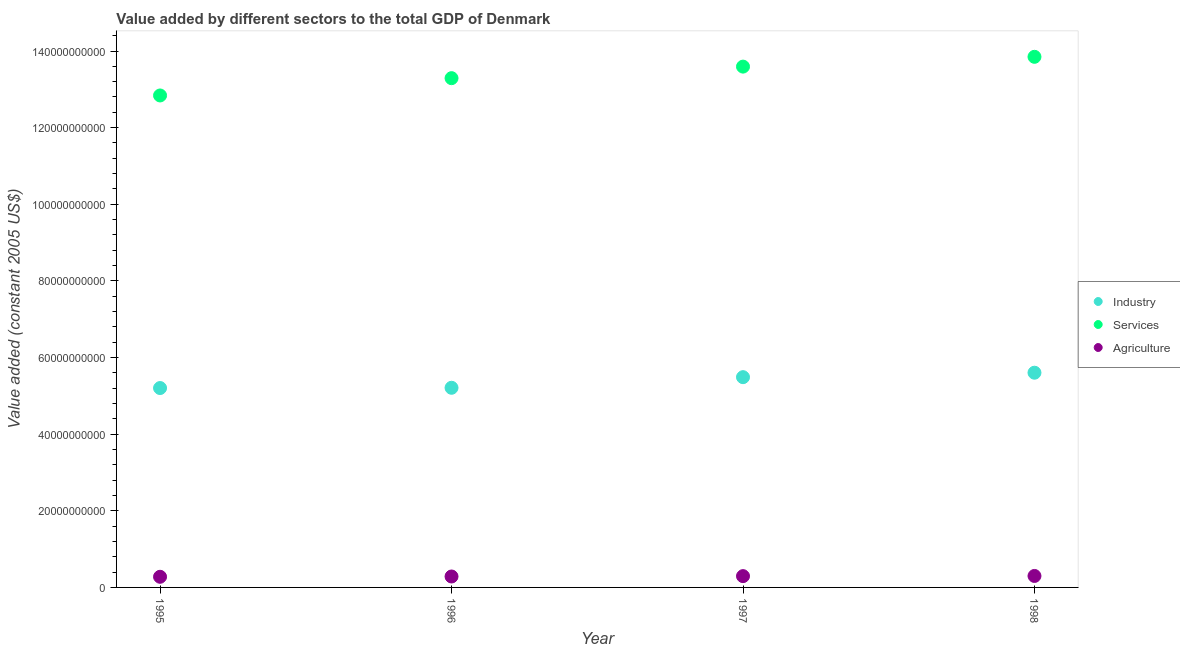What is the value added by services in 1997?
Offer a terse response. 1.36e+11. Across all years, what is the maximum value added by services?
Provide a succinct answer. 1.38e+11. Across all years, what is the minimum value added by industrial sector?
Make the answer very short. 5.20e+1. In which year was the value added by agricultural sector minimum?
Make the answer very short. 1995. What is the total value added by industrial sector in the graph?
Offer a terse response. 2.15e+11. What is the difference between the value added by industrial sector in 1995 and that in 1997?
Make the answer very short. -2.84e+09. What is the difference between the value added by industrial sector in 1997 and the value added by agricultural sector in 1998?
Your response must be concise. 5.19e+1. What is the average value added by services per year?
Offer a very short reply. 1.34e+11. In the year 1996, what is the difference between the value added by agricultural sector and value added by industrial sector?
Your answer should be compact. -4.93e+1. What is the ratio of the value added by services in 1995 to that in 1996?
Keep it short and to the point. 0.97. Is the value added by industrial sector in 1996 less than that in 1997?
Offer a terse response. Yes. What is the difference between the highest and the second highest value added by services?
Provide a short and direct response. 2.56e+09. What is the difference between the highest and the lowest value added by agricultural sector?
Your response must be concise. 2.16e+08. In how many years, is the value added by industrial sector greater than the average value added by industrial sector taken over all years?
Make the answer very short. 2. Does the value added by services monotonically increase over the years?
Make the answer very short. Yes. How many dotlines are there?
Your answer should be very brief. 3. How many years are there in the graph?
Ensure brevity in your answer.  4. What is the difference between two consecutive major ticks on the Y-axis?
Ensure brevity in your answer.  2.00e+1. Does the graph contain any zero values?
Offer a terse response. No. Does the graph contain grids?
Keep it short and to the point. No. How are the legend labels stacked?
Give a very brief answer. Vertical. What is the title of the graph?
Your answer should be compact. Value added by different sectors to the total GDP of Denmark. What is the label or title of the X-axis?
Make the answer very short. Year. What is the label or title of the Y-axis?
Your answer should be very brief. Value added (constant 2005 US$). What is the Value added (constant 2005 US$) of Industry in 1995?
Ensure brevity in your answer.  5.20e+1. What is the Value added (constant 2005 US$) in Services in 1995?
Offer a terse response. 1.28e+11. What is the Value added (constant 2005 US$) of Agriculture in 1995?
Ensure brevity in your answer.  2.78e+09. What is the Value added (constant 2005 US$) in Industry in 1996?
Give a very brief answer. 5.21e+1. What is the Value added (constant 2005 US$) in Services in 1996?
Give a very brief answer. 1.33e+11. What is the Value added (constant 2005 US$) of Agriculture in 1996?
Keep it short and to the point. 2.85e+09. What is the Value added (constant 2005 US$) of Industry in 1997?
Provide a succinct answer. 5.49e+1. What is the Value added (constant 2005 US$) of Services in 1997?
Provide a short and direct response. 1.36e+11. What is the Value added (constant 2005 US$) in Agriculture in 1997?
Your answer should be very brief. 2.95e+09. What is the Value added (constant 2005 US$) in Industry in 1998?
Give a very brief answer. 5.60e+1. What is the Value added (constant 2005 US$) in Services in 1998?
Keep it short and to the point. 1.38e+11. What is the Value added (constant 2005 US$) of Agriculture in 1998?
Ensure brevity in your answer.  2.99e+09. Across all years, what is the maximum Value added (constant 2005 US$) in Industry?
Your response must be concise. 5.60e+1. Across all years, what is the maximum Value added (constant 2005 US$) of Services?
Your response must be concise. 1.38e+11. Across all years, what is the maximum Value added (constant 2005 US$) of Agriculture?
Your response must be concise. 2.99e+09. Across all years, what is the minimum Value added (constant 2005 US$) of Industry?
Make the answer very short. 5.20e+1. Across all years, what is the minimum Value added (constant 2005 US$) in Services?
Provide a succinct answer. 1.28e+11. Across all years, what is the minimum Value added (constant 2005 US$) in Agriculture?
Provide a succinct answer. 2.78e+09. What is the total Value added (constant 2005 US$) in Industry in the graph?
Offer a very short reply. 2.15e+11. What is the total Value added (constant 2005 US$) in Services in the graph?
Provide a short and direct response. 5.36e+11. What is the total Value added (constant 2005 US$) in Agriculture in the graph?
Provide a short and direct response. 1.16e+1. What is the difference between the Value added (constant 2005 US$) in Industry in 1995 and that in 1996?
Your answer should be very brief. -6.66e+07. What is the difference between the Value added (constant 2005 US$) in Services in 1995 and that in 1996?
Provide a short and direct response. -4.52e+09. What is the difference between the Value added (constant 2005 US$) of Agriculture in 1995 and that in 1996?
Keep it short and to the point. -7.56e+07. What is the difference between the Value added (constant 2005 US$) in Industry in 1995 and that in 1997?
Provide a succinct answer. -2.84e+09. What is the difference between the Value added (constant 2005 US$) in Services in 1995 and that in 1997?
Your answer should be compact. -7.53e+09. What is the difference between the Value added (constant 2005 US$) of Agriculture in 1995 and that in 1997?
Your response must be concise. -1.71e+08. What is the difference between the Value added (constant 2005 US$) in Industry in 1995 and that in 1998?
Offer a very short reply. -4.00e+09. What is the difference between the Value added (constant 2005 US$) in Services in 1995 and that in 1998?
Offer a very short reply. -1.01e+1. What is the difference between the Value added (constant 2005 US$) of Agriculture in 1995 and that in 1998?
Provide a succinct answer. -2.16e+08. What is the difference between the Value added (constant 2005 US$) of Industry in 1996 and that in 1997?
Provide a short and direct response. -2.77e+09. What is the difference between the Value added (constant 2005 US$) of Services in 1996 and that in 1997?
Make the answer very short. -3.01e+09. What is the difference between the Value added (constant 2005 US$) in Agriculture in 1996 and that in 1997?
Your response must be concise. -9.59e+07. What is the difference between the Value added (constant 2005 US$) in Industry in 1996 and that in 1998?
Offer a terse response. -3.93e+09. What is the difference between the Value added (constant 2005 US$) in Services in 1996 and that in 1998?
Your response must be concise. -5.57e+09. What is the difference between the Value added (constant 2005 US$) of Agriculture in 1996 and that in 1998?
Offer a terse response. -1.40e+08. What is the difference between the Value added (constant 2005 US$) of Industry in 1997 and that in 1998?
Your answer should be very brief. -1.16e+09. What is the difference between the Value added (constant 2005 US$) in Services in 1997 and that in 1998?
Your answer should be compact. -2.56e+09. What is the difference between the Value added (constant 2005 US$) in Agriculture in 1997 and that in 1998?
Ensure brevity in your answer.  -4.46e+07. What is the difference between the Value added (constant 2005 US$) in Industry in 1995 and the Value added (constant 2005 US$) in Services in 1996?
Give a very brief answer. -8.09e+1. What is the difference between the Value added (constant 2005 US$) in Industry in 1995 and the Value added (constant 2005 US$) in Agriculture in 1996?
Ensure brevity in your answer.  4.92e+1. What is the difference between the Value added (constant 2005 US$) in Services in 1995 and the Value added (constant 2005 US$) in Agriculture in 1996?
Your answer should be very brief. 1.26e+11. What is the difference between the Value added (constant 2005 US$) in Industry in 1995 and the Value added (constant 2005 US$) in Services in 1997?
Your response must be concise. -8.39e+1. What is the difference between the Value added (constant 2005 US$) of Industry in 1995 and the Value added (constant 2005 US$) of Agriculture in 1997?
Offer a very short reply. 4.91e+1. What is the difference between the Value added (constant 2005 US$) of Services in 1995 and the Value added (constant 2005 US$) of Agriculture in 1997?
Offer a very short reply. 1.25e+11. What is the difference between the Value added (constant 2005 US$) in Industry in 1995 and the Value added (constant 2005 US$) in Services in 1998?
Your response must be concise. -8.64e+1. What is the difference between the Value added (constant 2005 US$) in Industry in 1995 and the Value added (constant 2005 US$) in Agriculture in 1998?
Provide a succinct answer. 4.90e+1. What is the difference between the Value added (constant 2005 US$) of Services in 1995 and the Value added (constant 2005 US$) of Agriculture in 1998?
Give a very brief answer. 1.25e+11. What is the difference between the Value added (constant 2005 US$) in Industry in 1996 and the Value added (constant 2005 US$) in Services in 1997?
Make the answer very short. -8.38e+1. What is the difference between the Value added (constant 2005 US$) of Industry in 1996 and the Value added (constant 2005 US$) of Agriculture in 1997?
Your response must be concise. 4.92e+1. What is the difference between the Value added (constant 2005 US$) in Services in 1996 and the Value added (constant 2005 US$) in Agriculture in 1997?
Provide a succinct answer. 1.30e+11. What is the difference between the Value added (constant 2005 US$) of Industry in 1996 and the Value added (constant 2005 US$) of Services in 1998?
Offer a very short reply. -8.64e+1. What is the difference between the Value added (constant 2005 US$) of Industry in 1996 and the Value added (constant 2005 US$) of Agriculture in 1998?
Offer a very short reply. 4.91e+1. What is the difference between the Value added (constant 2005 US$) of Services in 1996 and the Value added (constant 2005 US$) of Agriculture in 1998?
Your answer should be very brief. 1.30e+11. What is the difference between the Value added (constant 2005 US$) in Industry in 1997 and the Value added (constant 2005 US$) in Services in 1998?
Your answer should be very brief. -8.36e+1. What is the difference between the Value added (constant 2005 US$) in Industry in 1997 and the Value added (constant 2005 US$) in Agriculture in 1998?
Offer a terse response. 5.19e+1. What is the difference between the Value added (constant 2005 US$) of Services in 1997 and the Value added (constant 2005 US$) of Agriculture in 1998?
Ensure brevity in your answer.  1.33e+11. What is the average Value added (constant 2005 US$) in Industry per year?
Provide a succinct answer. 5.38e+1. What is the average Value added (constant 2005 US$) in Services per year?
Offer a very short reply. 1.34e+11. What is the average Value added (constant 2005 US$) of Agriculture per year?
Your response must be concise. 2.89e+09. In the year 1995, what is the difference between the Value added (constant 2005 US$) in Industry and Value added (constant 2005 US$) in Services?
Your answer should be compact. -7.64e+1. In the year 1995, what is the difference between the Value added (constant 2005 US$) in Industry and Value added (constant 2005 US$) in Agriculture?
Provide a succinct answer. 4.93e+1. In the year 1995, what is the difference between the Value added (constant 2005 US$) of Services and Value added (constant 2005 US$) of Agriculture?
Offer a terse response. 1.26e+11. In the year 1996, what is the difference between the Value added (constant 2005 US$) in Industry and Value added (constant 2005 US$) in Services?
Offer a terse response. -8.08e+1. In the year 1996, what is the difference between the Value added (constant 2005 US$) of Industry and Value added (constant 2005 US$) of Agriculture?
Offer a terse response. 4.93e+1. In the year 1996, what is the difference between the Value added (constant 2005 US$) of Services and Value added (constant 2005 US$) of Agriculture?
Your response must be concise. 1.30e+11. In the year 1997, what is the difference between the Value added (constant 2005 US$) in Industry and Value added (constant 2005 US$) in Services?
Provide a succinct answer. -8.10e+1. In the year 1997, what is the difference between the Value added (constant 2005 US$) of Industry and Value added (constant 2005 US$) of Agriculture?
Your response must be concise. 5.19e+1. In the year 1997, what is the difference between the Value added (constant 2005 US$) in Services and Value added (constant 2005 US$) in Agriculture?
Provide a succinct answer. 1.33e+11. In the year 1998, what is the difference between the Value added (constant 2005 US$) in Industry and Value added (constant 2005 US$) in Services?
Ensure brevity in your answer.  -8.24e+1. In the year 1998, what is the difference between the Value added (constant 2005 US$) of Industry and Value added (constant 2005 US$) of Agriculture?
Give a very brief answer. 5.30e+1. In the year 1998, what is the difference between the Value added (constant 2005 US$) in Services and Value added (constant 2005 US$) in Agriculture?
Give a very brief answer. 1.35e+11. What is the ratio of the Value added (constant 2005 US$) of Industry in 1995 to that in 1996?
Your answer should be compact. 1. What is the ratio of the Value added (constant 2005 US$) in Services in 1995 to that in 1996?
Make the answer very short. 0.97. What is the ratio of the Value added (constant 2005 US$) of Agriculture in 1995 to that in 1996?
Ensure brevity in your answer.  0.97. What is the ratio of the Value added (constant 2005 US$) in Industry in 1995 to that in 1997?
Offer a very short reply. 0.95. What is the ratio of the Value added (constant 2005 US$) in Services in 1995 to that in 1997?
Provide a succinct answer. 0.94. What is the ratio of the Value added (constant 2005 US$) of Agriculture in 1995 to that in 1997?
Your answer should be very brief. 0.94. What is the ratio of the Value added (constant 2005 US$) in Industry in 1995 to that in 1998?
Your response must be concise. 0.93. What is the ratio of the Value added (constant 2005 US$) of Services in 1995 to that in 1998?
Your response must be concise. 0.93. What is the ratio of the Value added (constant 2005 US$) of Agriculture in 1995 to that in 1998?
Your answer should be compact. 0.93. What is the ratio of the Value added (constant 2005 US$) in Industry in 1996 to that in 1997?
Your answer should be very brief. 0.95. What is the ratio of the Value added (constant 2005 US$) in Services in 1996 to that in 1997?
Your answer should be compact. 0.98. What is the ratio of the Value added (constant 2005 US$) in Agriculture in 1996 to that in 1997?
Keep it short and to the point. 0.97. What is the ratio of the Value added (constant 2005 US$) in Industry in 1996 to that in 1998?
Offer a very short reply. 0.93. What is the ratio of the Value added (constant 2005 US$) of Services in 1996 to that in 1998?
Provide a succinct answer. 0.96. What is the ratio of the Value added (constant 2005 US$) in Agriculture in 1996 to that in 1998?
Provide a short and direct response. 0.95. What is the ratio of the Value added (constant 2005 US$) in Industry in 1997 to that in 1998?
Your answer should be very brief. 0.98. What is the ratio of the Value added (constant 2005 US$) in Services in 1997 to that in 1998?
Provide a short and direct response. 0.98. What is the ratio of the Value added (constant 2005 US$) of Agriculture in 1997 to that in 1998?
Give a very brief answer. 0.99. What is the difference between the highest and the second highest Value added (constant 2005 US$) of Industry?
Your response must be concise. 1.16e+09. What is the difference between the highest and the second highest Value added (constant 2005 US$) in Services?
Make the answer very short. 2.56e+09. What is the difference between the highest and the second highest Value added (constant 2005 US$) of Agriculture?
Offer a very short reply. 4.46e+07. What is the difference between the highest and the lowest Value added (constant 2005 US$) of Industry?
Offer a terse response. 4.00e+09. What is the difference between the highest and the lowest Value added (constant 2005 US$) of Services?
Keep it short and to the point. 1.01e+1. What is the difference between the highest and the lowest Value added (constant 2005 US$) in Agriculture?
Ensure brevity in your answer.  2.16e+08. 